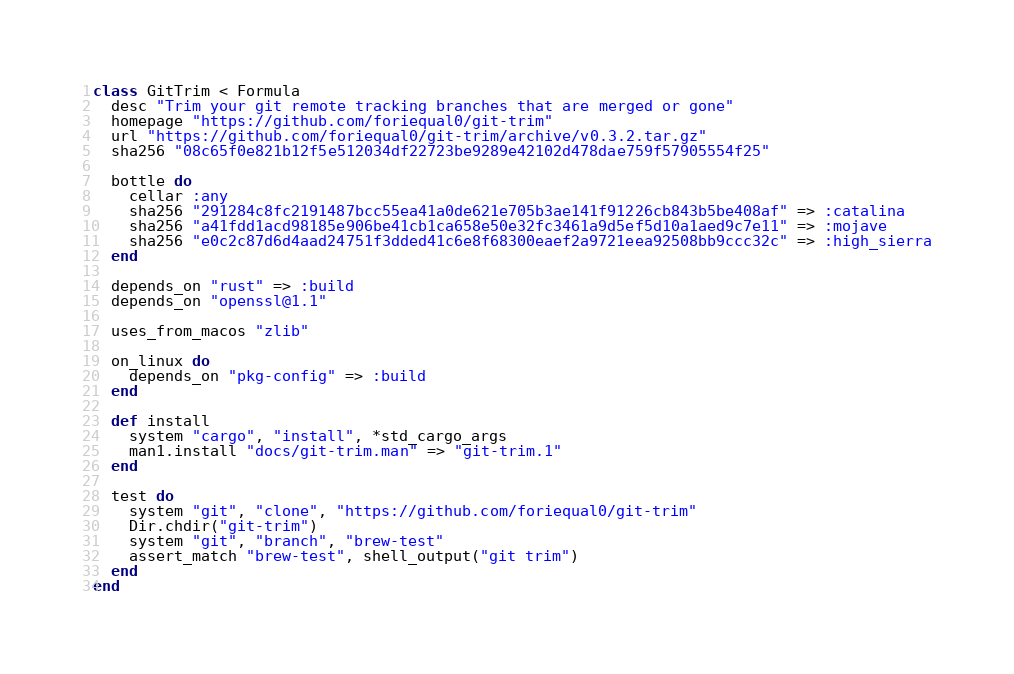Convert code to text. <code><loc_0><loc_0><loc_500><loc_500><_Ruby_>class GitTrim < Formula
  desc "Trim your git remote tracking branches that are merged or gone"
  homepage "https://github.com/foriequal0/git-trim"
  url "https://github.com/foriequal0/git-trim/archive/v0.3.2.tar.gz"
  sha256 "08c65f0e821b12f5e512034df22723be9289e42102d478dae759f57905554f25"

  bottle do
    cellar :any
    sha256 "291284c8fc2191487bcc55ea41a0de621e705b3ae141f91226cb843b5be408af" => :catalina
    sha256 "a41fdd1acd98185e906be41cb1ca658e50e32fc3461a9d5ef5d10a1aed9c7e11" => :mojave
    sha256 "e0c2c87d6d4aad24751f3dded41c6e8f68300eaef2a9721eea92508bb9ccc32c" => :high_sierra
  end

  depends_on "rust" => :build
  depends_on "openssl@1.1"

  uses_from_macos "zlib"

  on_linux do
    depends_on "pkg-config" => :build
  end

  def install
    system "cargo", "install", *std_cargo_args
    man1.install "docs/git-trim.man" => "git-trim.1"
  end

  test do
    system "git", "clone", "https://github.com/foriequal0/git-trim"
    Dir.chdir("git-trim")
    system "git", "branch", "brew-test"
    assert_match "brew-test", shell_output("git trim")
  end
end
</code> 